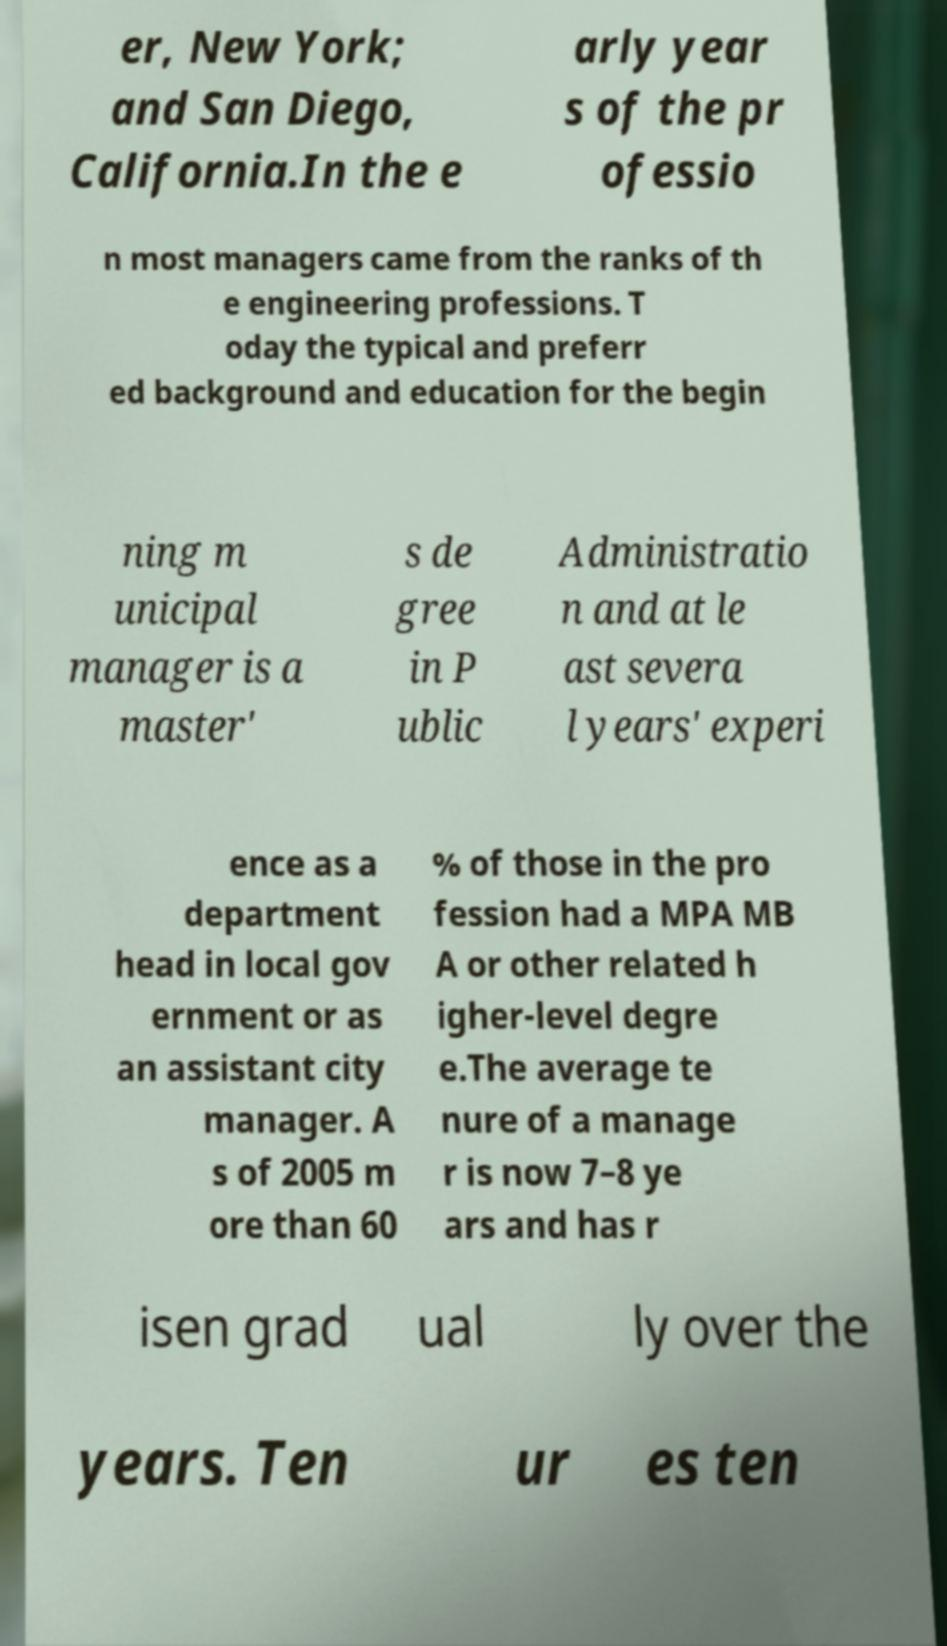Can you accurately transcribe the text from the provided image for me? er, New York; and San Diego, California.In the e arly year s of the pr ofessio n most managers came from the ranks of th e engineering professions. T oday the typical and preferr ed background and education for the begin ning m unicipal manager is a master' s de gree in P ublic Administratio n and at le ast severa l years' experi ence as a department head in local gov ernment or as an assistant city manager. A s of 2005 m ore than 60 % of those in the pro fession had a MPA MB A or other related h igher-level degre e.The average te nure of a manage r is now 7–8 ye ars and has r isen grad ual ly over the years. Ten ur es ten 